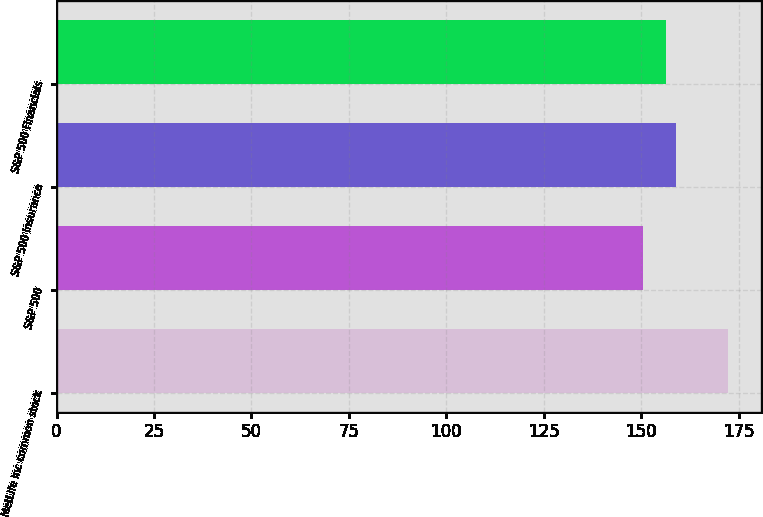Convert chart. <chart><loc_0><loc_0><loc_500><loc_500><bar_chart><fcel>MetLife Inc common stock<fcel>S&P 500<fcel>S&P 500 Insurance<fcel>S&P 500 Financials<nl><fcel>172.2<fcel>150.51<fcel>158.86<fcel>156.25<nl></chart> 